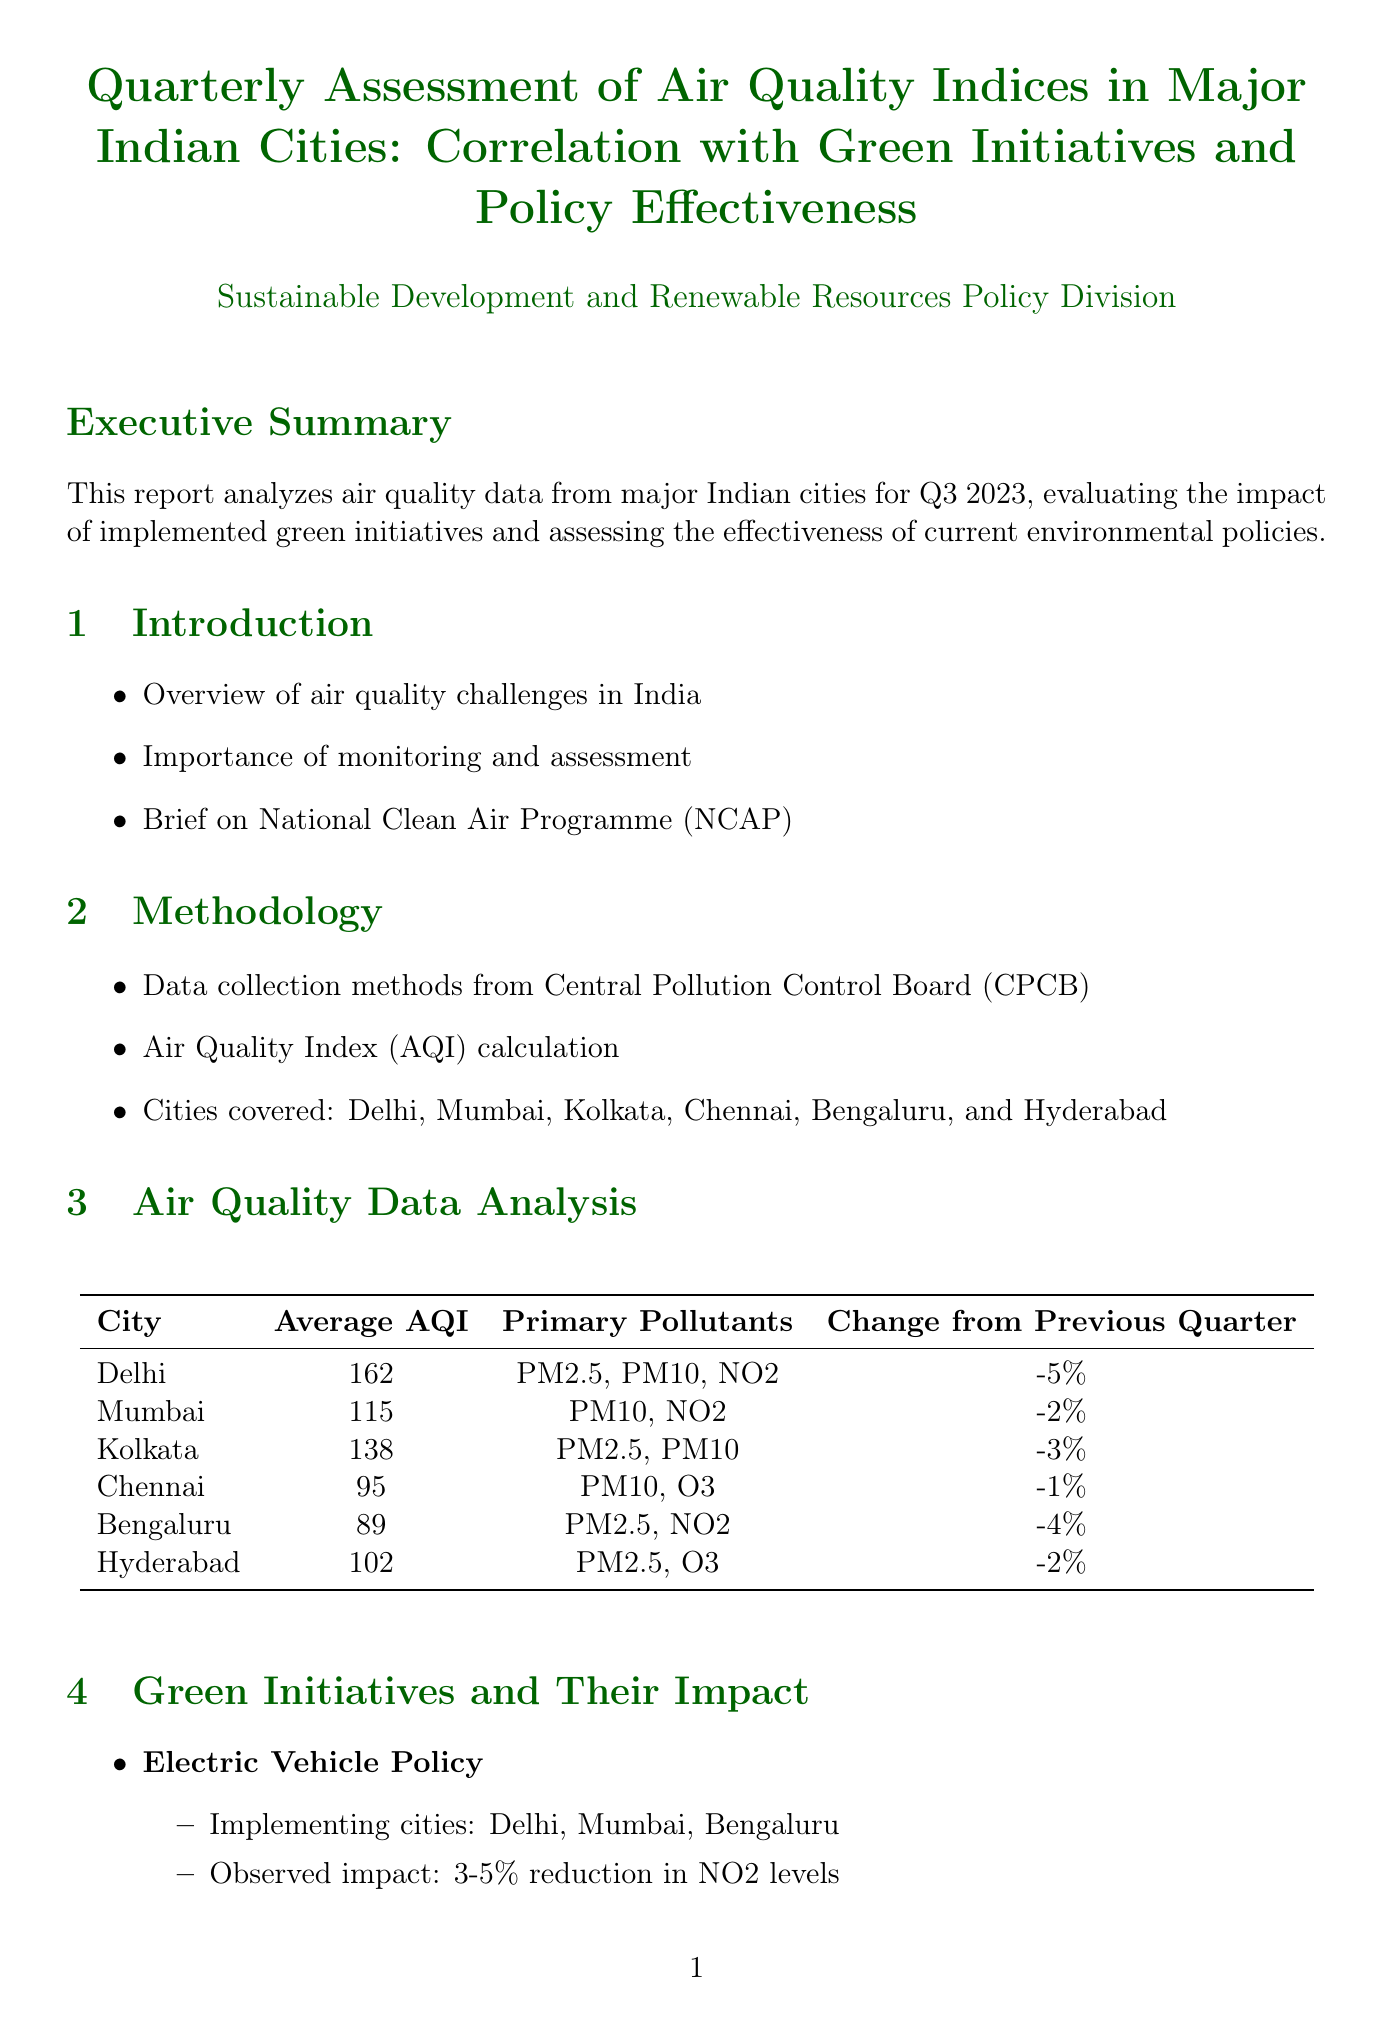what was the average AQI in Delhi? The average AQI for Delhi is stated as 162 in the air quality data analysis section.
Answer: 162 which green initiative showed a 3-5% reduction in NO2 levels? The initiative that showed this reduction is the Electric Vehicle Policy as detailed in the green initiatives section.
Answer: Electric Vehicle Policy what is the effectiveness rating of the National Clean Air Programme (NCAP)? The effectiveness rating for NCAP is found in the policy effectiveness analysis section, which states it is "Moderate."
Answer: Moderate how many cities are covered in the air quality data analysis? The document mentions six cities covered: Delhi, Mumbai, Kolkata, Chennai, Bengaluru, and Hyderabad.
Answer: six what was the change in average AQI for Chennai from the previous quarter? The data under Chennai shows a change of -1% from the previous quarter.
Answer: -1% which city had the lowest average AQI in Q3 2023? According to the table in the air quality data analysis section, Bengaluru has the lowest average AQI of 89.
Answer: Bengaluru what are the areas for improvement in the BS-VI Fuel Standards policy? The document outlines areas for improvement which include "Accelerating the phase-out of older vehicles" and "Enhancing compliance monitoring."
Answer: Accelerating the phase-out of older vehicles, Enhancing compliance monitoring how much overall AQI improvement was observed due to Waste Management and Anti-burning Campaigns? The observed impact in the green initiatives section specifies a 2-3% improvement in overall AQI.
Answer: 2-3% which primary pollutants were noted for Mumbai? The primary pollutants listed for Mumbai are PM10 and NO2 as shown in the air quality data analysis section.
Answer: PM10, NO2 